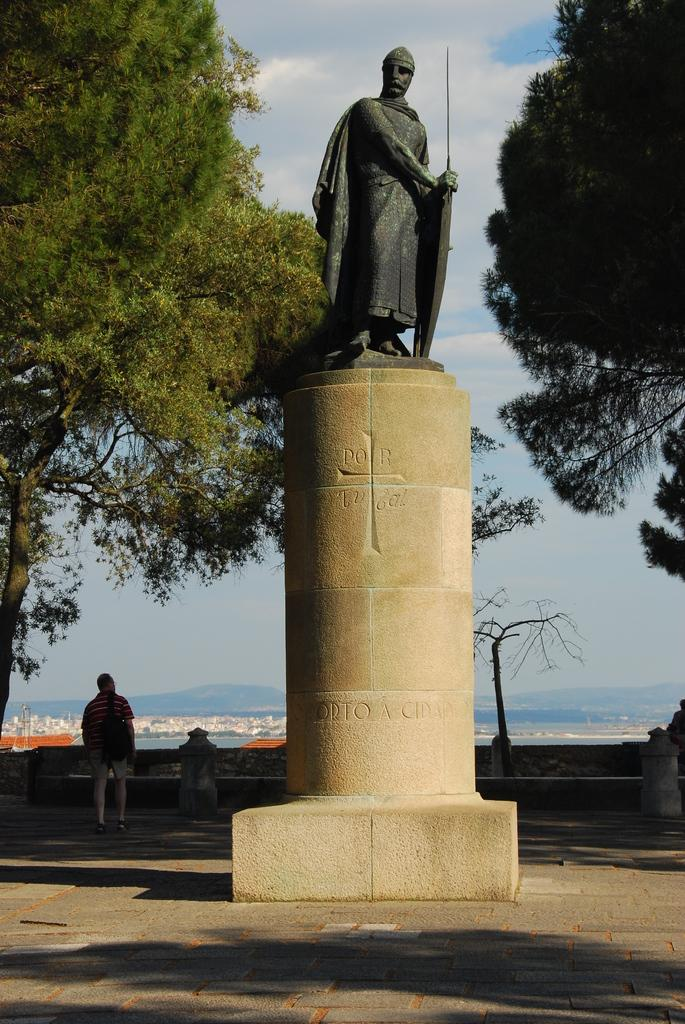What is the main subject in the center of the image? There is a statue in the center of the image. How is the statue positioned in the image? The statue is on a pedestal. What can be seen on the left side of the image? There is a man standing on the left side of the image. What type of natural environment is visible in the image? Trees and hills are visible in the image, and the sky is visible in the background. Where is the entrance to the cellar located in the image? There is no cellar present in the image. What type of home is depicted in the image? The image does not show a home; it features a statue, a man, trees, hills, and the sky. 